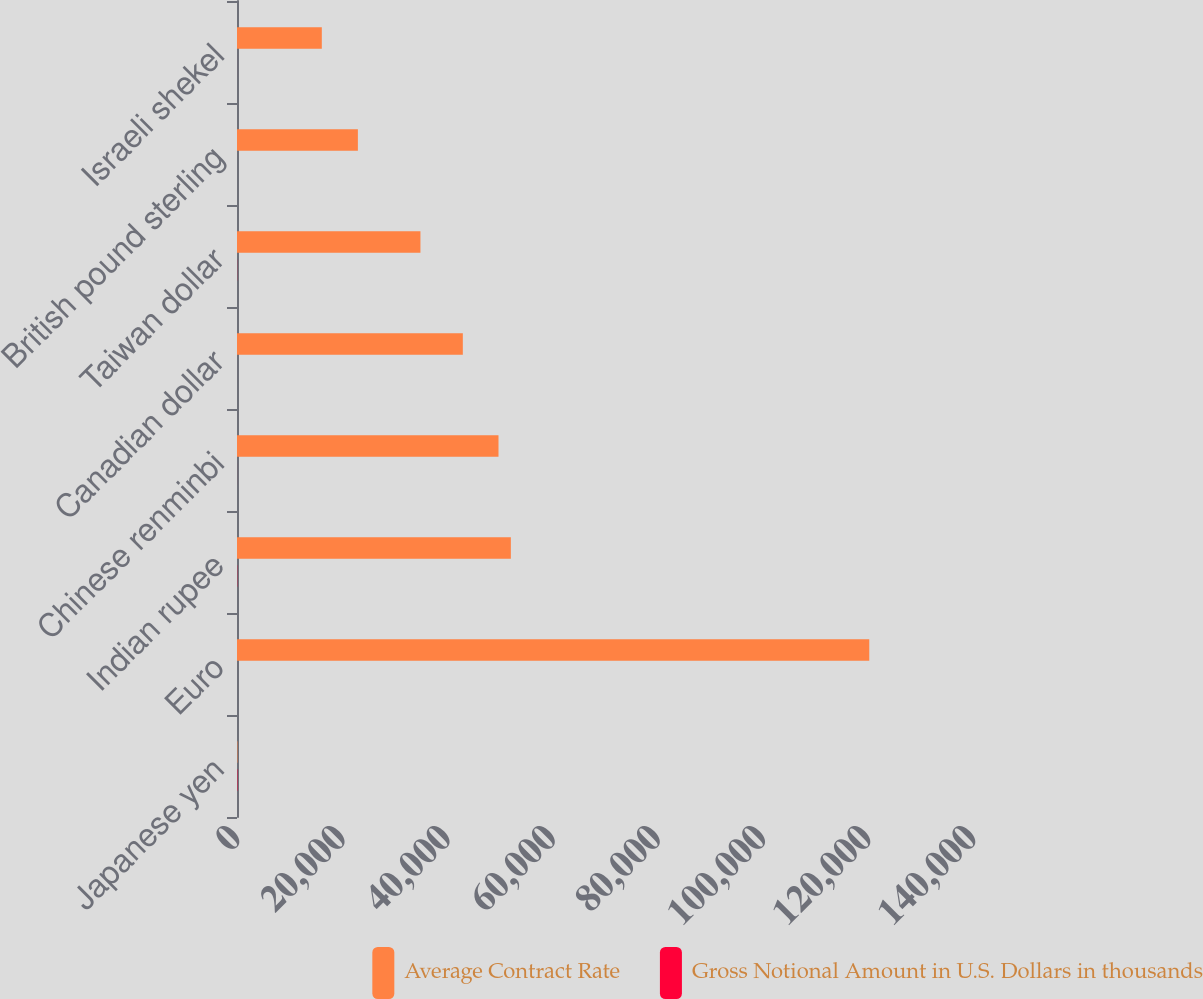Convert chart. <chart><loc_0><loc_0><loc_500><loc_500><stacked_bar_chart><ecel><fcel>Japanese yen<fcel>Euro<fcel>Indian rupee<fcel>Chinese renminbi<fcel>Canadian dollar<fcel>Taiwan dollar<fcel>British pound sterling<fcel>Israeli shekel<nl><fcel>Average Contract Rate<fcel>78.52<fcel>120268<fcel>52092<fcel>49743<fcel>42956<fcel>34895<fcel>22994<fcel>16133<nl><fcel>Gross Notional Amount in U.S. Dollars in thousands<fcel>78.52<fcel>0.72<fcel>47.63<fcel>6.39<fcel>1<fcel>28.75<fcel>0.63<fcel>3.5<nl></chart> 